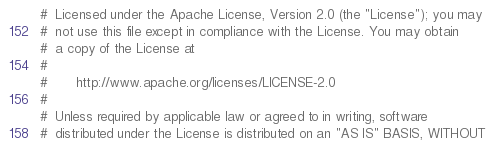Convert code to text. <code><loc_0><loc_0><loc_500><loc_500><_Python_>#  Licensed under the Apache License, Version 2.0 (the "License"); you may
#  not use this file except in compliance with the License. You may obtain
#  a copy of the License at
#
#       http://www.apache.org/licenses/LICENSE-2.0
#
#  Unless required by applicable law or agreed to in writing, software
#  distributed under the License is distributed on an "AS IS" BASIS, WITHOUT</code> 